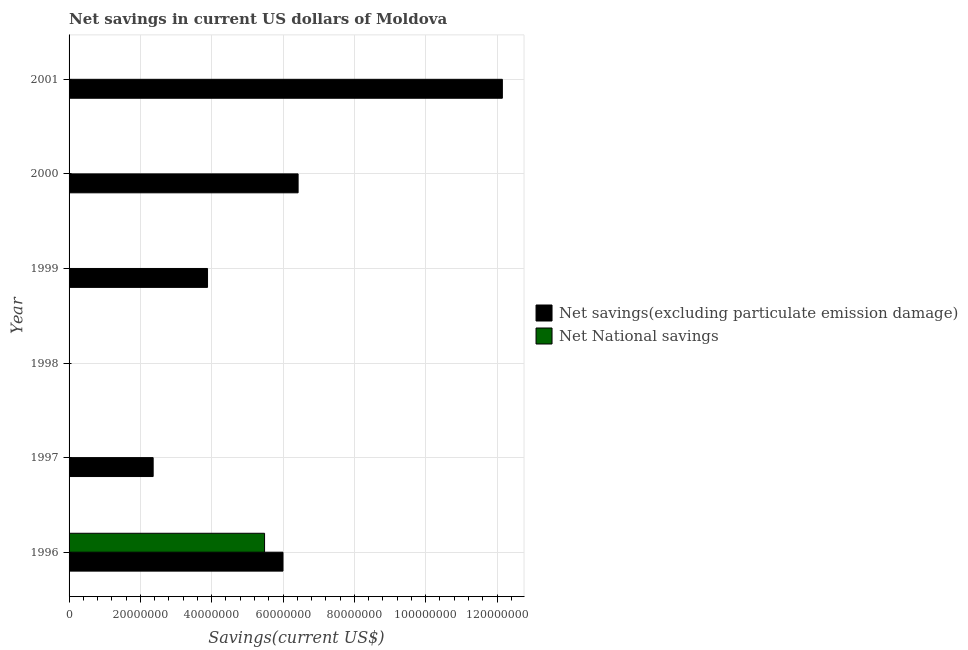Are the number of bars per tick equal to the number of legend labels?
Your response must be concise. No. How many bars are there on the 2nd tick from the bottom?
Offer a terse response. 1. In how many cases, is the number of bars for a given year not equal to the number of legend labels?
Your response must be concise. 5. What is the net national savings in 1997?
Provide a short and direct response. 0. Across all years, what is the maximum net savings(excluding particulate emission damage)?
Ensure brevity in your answer.  1.21e+08. What is the total net national savings in the graph?
Your answer should be very brief. 5.48e+07. What is the difference between the net savings(excluding particulate emission damage) in 1999 and that in 2000?
Give a very brief answer. -2.54e+07. What is the difference between the net national savings in 2000 and the net savings(excluding particulate emission damage) in 1997?
Ensure brevity in your answer.  -2.36e+07. What is the average net national savings per year?
Your response must be concise. 9.14e+06. What is the ratio of the net savings(excluding particulate emission damage) in 1996 to that in 2001?
Your response must be concise. 0.49. What is the difference between the highest and the second highest net savings(excluding particulate emission damage)?
Your answer should be very brief. 5.73e+07. What is the difference between the highest and the lowest net national savings?
Keep it short and to the point. 5.48e+07. What is the difference between two consecutive major ticks on the X-axis?
Offer a terse response. 2.00e+07. Are the values on the major ticks of X-axis written in scientific E-notation?
Your answer should be compact. No. Does the graph contain any zero values?
Offer a very short reply. Yes. Where does the legend appear in the graph?
Provide a succinct answer. Center right. How are the legend labels stacked?
Give a very brief answer. Vertical. What is the title of the graph?
Provide a succinct answer. Net savings in current US dollars of Moldova. Does "Taxes on profits and capital gains" appear as one of the legend labels in the graph?
Offer a very short reply. No. What is the label or title of the X-axis?
Offer a very short reply. Savings(current US$). What is the Savings(current US$) in Net savings(excluding particulate emission damage) in 1996?
Your response must be concise. 6.00e+07. What is the Savings(current US$) of Net National savings in 1996?
Offer a terse response. 5.48e+07. What is the Savings(current US$) of Net savings(excluding particulate emission damage) in 1997?
Give a very brief answer. 2.36e+07. What is the Savings(current US$) in Net savings(excluding particulate emission damage) in 1998?
Offer a very short reply. 0. What is the Savings(current US$) of Net National savings in 1998?
Ensure brevity in your answer.  0. What is the Savings(current US$) in Net savings(excluding particulate emission damage) in 1999?
Provide a short and direct response. 3.88e+07. What is the Savings(current US$) of Net National savings in 1999?
Provide a succinct answer. 0. What is the Savings(current US$) in Net savings(excluding particulate emission damage) in 2000?
Provide a short and direct response. 6.42e+07. What is the Savings(current US$) of Net savings(excluding particulate emission damage) in 2001?
Your answer should be compact. 1.21e+08. Across all years, what is the maximum Savings(current US$) of Net savings(excluding particulate emission damage)?
Make the answer very short. 1.21e+08. Across all years, what is the maximum Savings(current US$) in Net National savings?
Offer a very short reply. 5.48e+07. Across all years, what is the minimum Savings(current US$) in Net National savings?
Offer a terse response. 0. What is the total Savings(current US$) of Net savings(excluding particulate emission damage) in the graph?
Offer a very short reply. 3.08e+08. What is the total Savings(current US$) of Net National savings in the graph?
Your answer should be compact. 5.48e+07. What is the difference between the Savings(current US$) in Net savings(excluding particulate emission damage) in 1996 and that in 1997?
Your answer should be compact. 3.64e+07. What is the difference between the Savings(current US$) in Net savings(excluding particulate emission damage) in 1996 and that in 1999?
Offer a terse response. 2.12e+07. What is the difference between the Savings(current US$) of Net savings(excluding particulate emission damage) in 1996 and that in 2000?
Offer a terse response. -4.24e+06. What is the difference between the Savings(current US$) in Net savings(excluding particulate emission damage) in 1996 and that in 2001?
Offer a terse response. -6.15e+07. What is the difference between the Savings(current US$) in Net savings(excluding particulate emission damage) in 1997 and that in 1999?
Give a very brief answer. -1.53e+07. What is the difference between the Savings(current US$) of Net savings(excluding particulate emission damage) in 1997 and that in 2000?
Ensure brevity in your answer.  -4.06e+07. What is the difference between the Savings(current US$) in Net savings(excluding particulate emission damage) in 1997 and that in 2001?
Provide a short and direct response. -9.79e+07. What is the difference between the Savings(current US$) in Net savings(excluding particulate emission damage) in 1999 and that in 2000?
Keep it short and to the point. -2.54e+07. What is the difference between the Savings(current US$) in Net savings(excluding particulate emission damage) in 1999 and that in 2001?
Make the answer very short. -8.27e+07. What is the difference between the Savings(current US$) of Net savings(excluding particulate emission damage) in 2000 and that in 2001?
Give a very brief answer. -5.73e+07. What is the average Savings(current US$) in Net savings(excluding particulate emission damage) per year?
Offer a terse response. 5.13e+07. What is the average Savings(current US$) in Net National savings per year?
Ensure brevity in your answer.  9.14e+06. In the year 1996, what is the difference between the Savings(current US$) in Net savings(excluding particulate emission damage) and Savings(current US$) in Net National savings?
Give a very brief answer. 5.17e+06. What is the ratio of the Savings(current US$) of Net savings(excluding particulate emission damage) in 1996 to that in 1997?
Provide a short and direct response. 2.54. What is the ratio of the Savings(current US$) of Net savings(excluding particulate emission damage) in 1996 to that in 1999?
Provide a short and direct response. 1.54. What is the ratio of the Savings(current US$) of Net savings(excluding particulate emission damage) in 1996 to that in 2000?
Your answer should be very brief. 0.93. What is the ratio of the Savings(current US$) in Net savings(excluding particulate emission damage) in 1996 to that in 2001?
Offer a terse response. 0.49. What is the ratio of the Savings(current US$) in Net savings(excluding particulate emission damage) in 1997 to that in 1999?
Your response must be concise. 0.61. What is the ratio of the Savings(current US$) in Net savings(excluding particulate emission damage) in 1997 to that in 2000?
Offer a terse response. 0.37. What is the ratio of the Savings(current US$) in Net savings(excluding particulate emission damage) in 1997 to that in 2001?
Provide a succinct answer. 0.19. What is the ratio of the Savings(current US$) in Net savings(excluding particulate emission damage) in 1999 to that in 2000?
Provide a short and direct response. 0.6. What is the ratio of the Savings(current US$) in Net savings(excluding particulate emission damage) in 1999 to that in 2001?
Give a very brief answer. 0.32. What is the ratio of the Savings(current US$) of Net savings(excluding particulate emission damage) in 2000 to that in 2001?
Keep it short and to the point. 0.53. What is the difference between the highest and the second highest Savings(current US$) in Net savings(excluding particulate emission damage)?
Make the answer very short. 5.73e+07. What is the difference between the highest and the lowest Savings(current US$) in Net savings(excluding particulate emission damage)?
Give a very brief answer. 1.21e+08. What is the difference between the highest and the lowest Savings(current US$) in Net National savings?
Your answer should be very brief. 5.48e+07. 